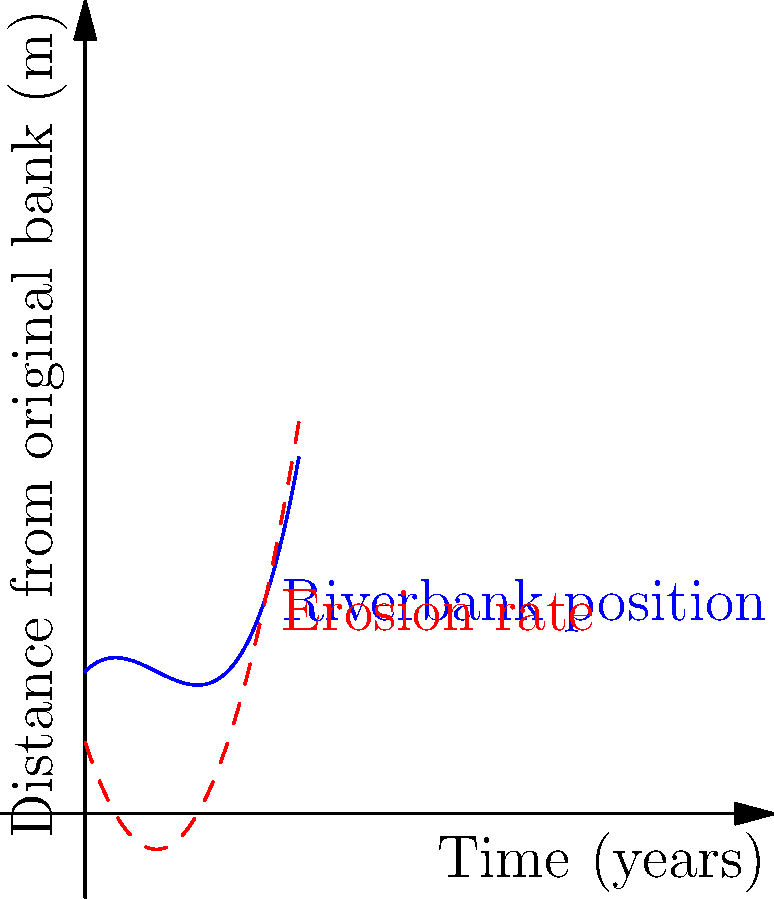Given the graph showing riverbank erosion over time, where the blue curve represents the position of the riverbank and the red dashed curve represents the erosion rate, determine the point of maximum curvature. How does this relate to the authenticity of digital records tracking riverbank changes? To find the point of maximum curvature, we need to follow these steps:

1) The curvature of a function $f(x)$ is given by:

   $\kappa = \frac{|f''(x)|}{(1 + (f'(x))^2)^{3/2}}$

2) To maximize this, we need to find where its derivative is zero. However, this is complex, so we'll use a simplification: the point of maximum curvature often occurs where $|f''(x)|$ is maximum.

3) The blue curve represents $f(x) = 0.5x^3 - 1.5x^2 + x + 2$

4) $f'(x) = 1.5x^2 - 3x + 1$ (represented by the red dashed curve)

5) $f''(x) = 3x - 3$

6) To find where $|f''(x)|$ is maximum, we solve $f''(x) = 0$:
   $3x - 3 = 0$
   $x = 1$

7) This point $(1, f(1))$ is where the curvature is maximum.

Regarding authenticity: This mathematical analysis provides a precise point of maximum change in erosion rate. If digital records don't align with this calculated point, it could raise questions about their accuracy or the methods used to collect the data.
Answer: Maximum curvature at $x=1$; discrepancies with this point may challenge digital record authenticity. 